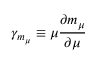Convert formula to latex. <formula><loc_0><loc_0><loc_500><loc_500>\gamma _ { m _ { \mu } } \equiv \mu \frac { \partial m _ { \mu } } { \partial \mu }</formula> 